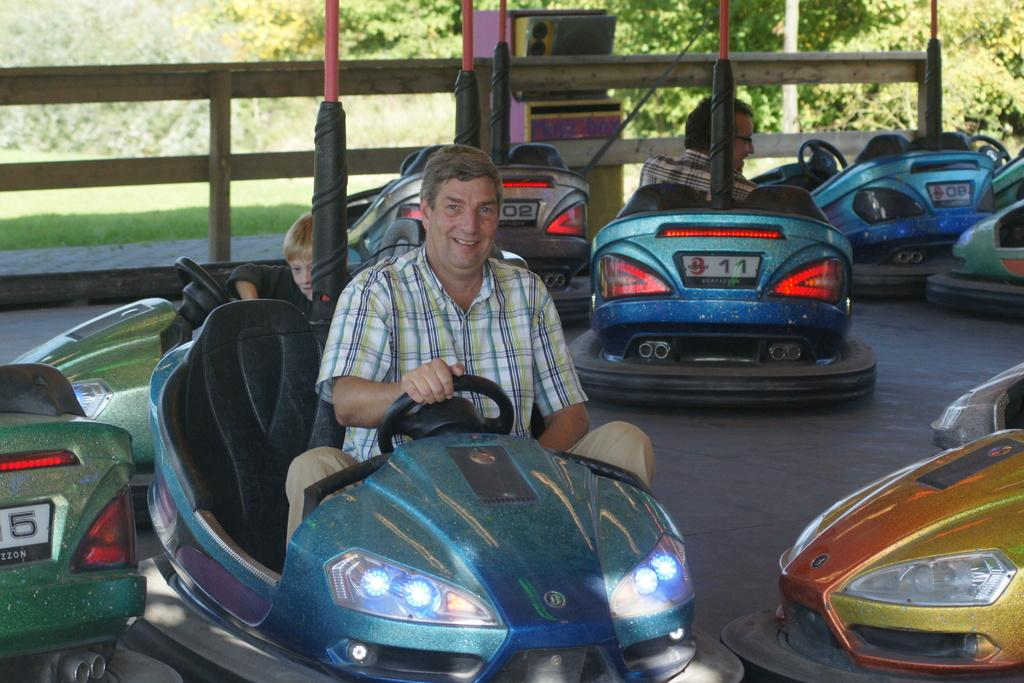What can be seen in large numbers in the image? There are many cars in the image. What type of natural elements are present in the image? There are numerous trees and grass visible in the image. What man-made object is present on the surface in the image? There is a machine on the surface in the image. What type of barrier can be seen in the image? There is a wooden fence in the image. How many people are present in the image? There are two persons in the image. What activity is the boy engaged in with a toy car in the image? There is a boy driving a toy car in the image. What type of beast can be seen resting in the image? There is no beast present in the image, nor is there any indication of a resting animal. What type of bear is visible in the image? There is no bear present in the image. 